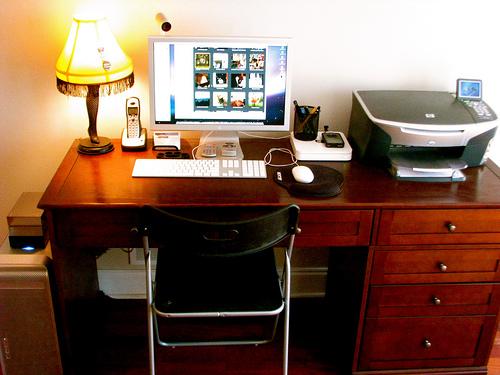Is there a video camera attached to the computer?
Be succinct. Yes. Is there a printer?
Concise answer only. Yes. What is the bulkiest piece of electronic equipment on the desk?
Give a very brief answer. Printer. 